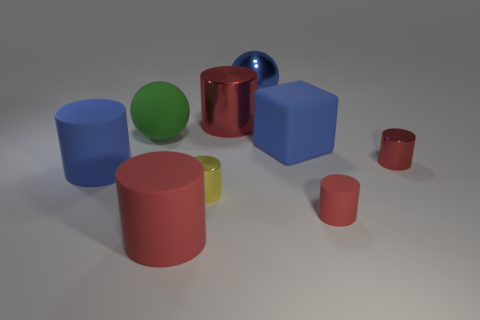What is the size of the shiny object that is the same color as the big metal cylinder?
Your answer should be compact. Small. There is a sphere that is behind the large red cylinder that is behind the big rubber ball; are there any shiny cylinders in front of it?
Give a very brief answer. Yes. Does the large metal thing right of the large shiny cylinder have the same shape as the green thing?
Give a very brief answer. Yes. There is a blue matte object behind the blue thing to the left of the large red metal object; what is its shape?
Offer a very short reply. Cube. What size is the red shiny thing that is right of the thing behind the big metal object that is left of the big blue shiny ball?
Give a very brief answer. Small. What color is the other small shiny thing that is the same shape as the small yellow metallic object?
Ensure brevity in your answer.  Red. Is the size of the blue metal sphere the same as the green ball?
Offer a terse response. Yes. There is a large red cylinder left of the tiny yellow metallic cylinder; what material is it?
Your answer should be compact. Rubber. What number of other objects are there of the same shape as the small red metallic object?
Ensure brevity in your answer.  5. Is the big red rubber object the same shape as the yellow object?
Your answer should be very brief. Yes. 